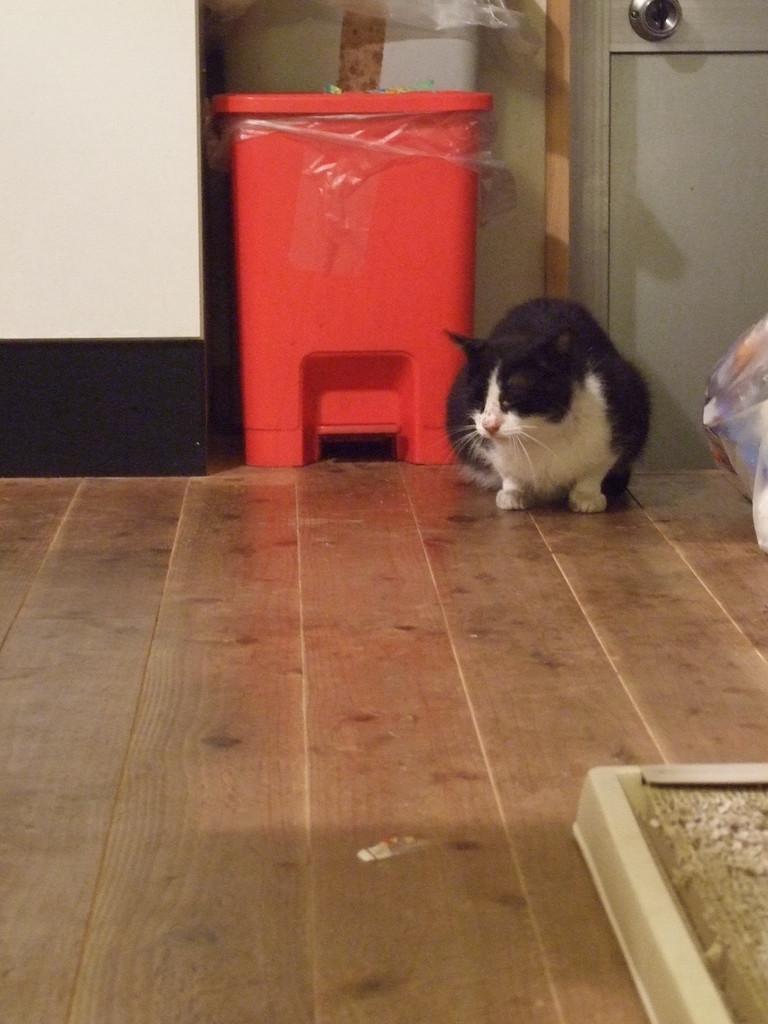Can you describe this image briefly? In this image there is a floor in the bottom of this image and there is a black and white cat on the right side of this image and there is a wall in the background. There is a red color object is kept on the top of this image. 